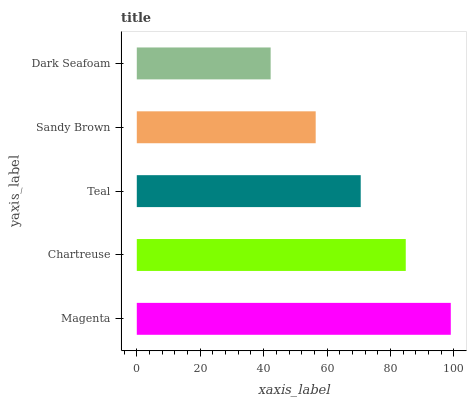Is Dark Seafoam the minimum?
Answer yes or no. Yes. Is Magenta the maximum?
Answer yes or no. Yes. Is Chartreuse the minimum?
Answer yes or no. No. Is Chartreuse the maximum?
Answer yes or no. No. Is Magenta greater than Chartreuse?
Answer yes or no. Yes. Is Chartreuse less than Magenta?
Answer yes or no. Yes. Is Chartreuse greater than Magenta?
Answer yes or no. No. Is Magenta less than Chartreuse?
Answer yes or no. No. Is Teal the high median?
Answer yes or no. Yes. Is Teal the low median?
Answer yes or no. Yes. Is Dark Seafoam the high median?
Answer yes or no. No. Is Sandy Brown the low median?
Answer yes or no. No. 